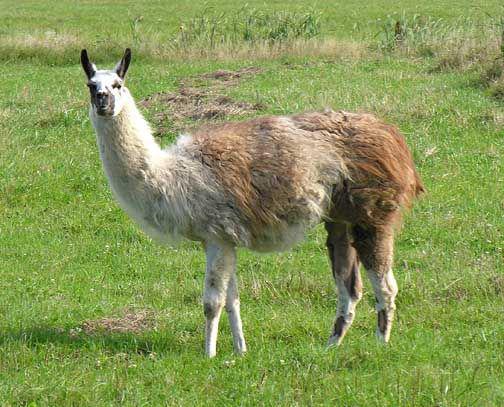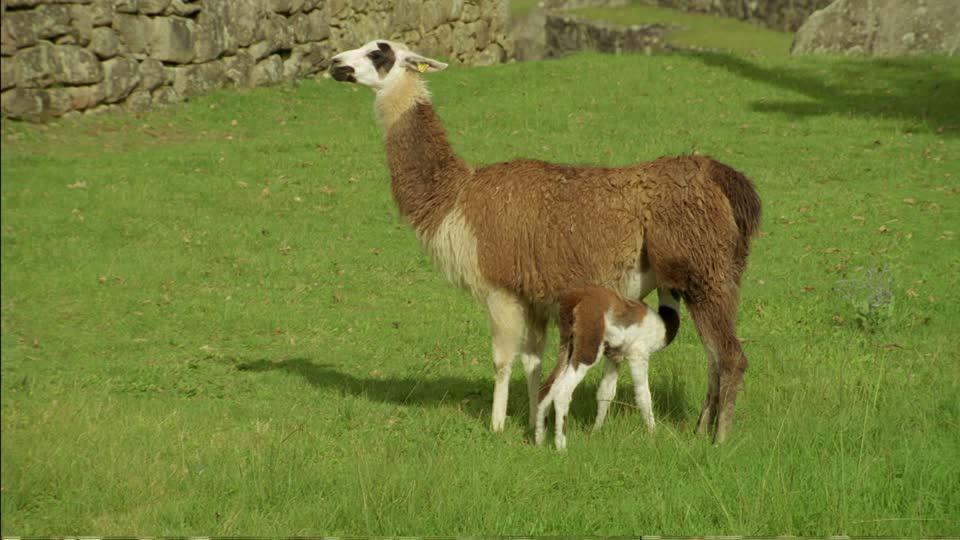The first image is the image on the left, the second image is the image on the right. Analyze the images presented: Is the assertion "The left and right image contains the same number of llamas." valid? Answer yes or no. No. 